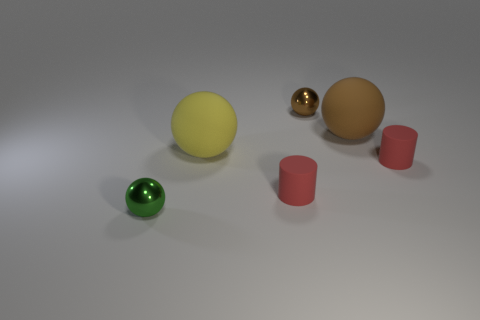What number of cylinders are behind the tiny shiny sphere that is to the right of the tiny green ball?
Provide a short and direct response. 0. How many spheres are small things or tiny brown shiny objects?
Make the answer very short. 2. Is there a red rubber ball?
Offer a terse response. No. What is the size of the yellow matte thing that is the same shape as the green thing?
Your answer should be very brief. Large. There is a small shiny object behind the small shiny thing left of the big yellow rubber ball; what shape is it?
Provide a short and direct response. Sphere. What number of brown objects are large matte objects or tiny matte things?
Ensure brevity in your answer.  1. Does the green object have the same size as the brown matte thing?
Your answer should be compact. No. Is there any other thing that is the same shape as the brown matte thing?
Provide a short and direct response. Yes. Does the big yellow sphere have the same material as the tiny sphere that is behind the tiny green metal thing?
Your answer should be compact. No. How many tiny things are both in front of the yellow ball and behind the tiny green metal object?
Give a very brief answer. 2. 